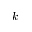<formula> <loc_0><loc_0><loc_500><loc_500>k</formula> 